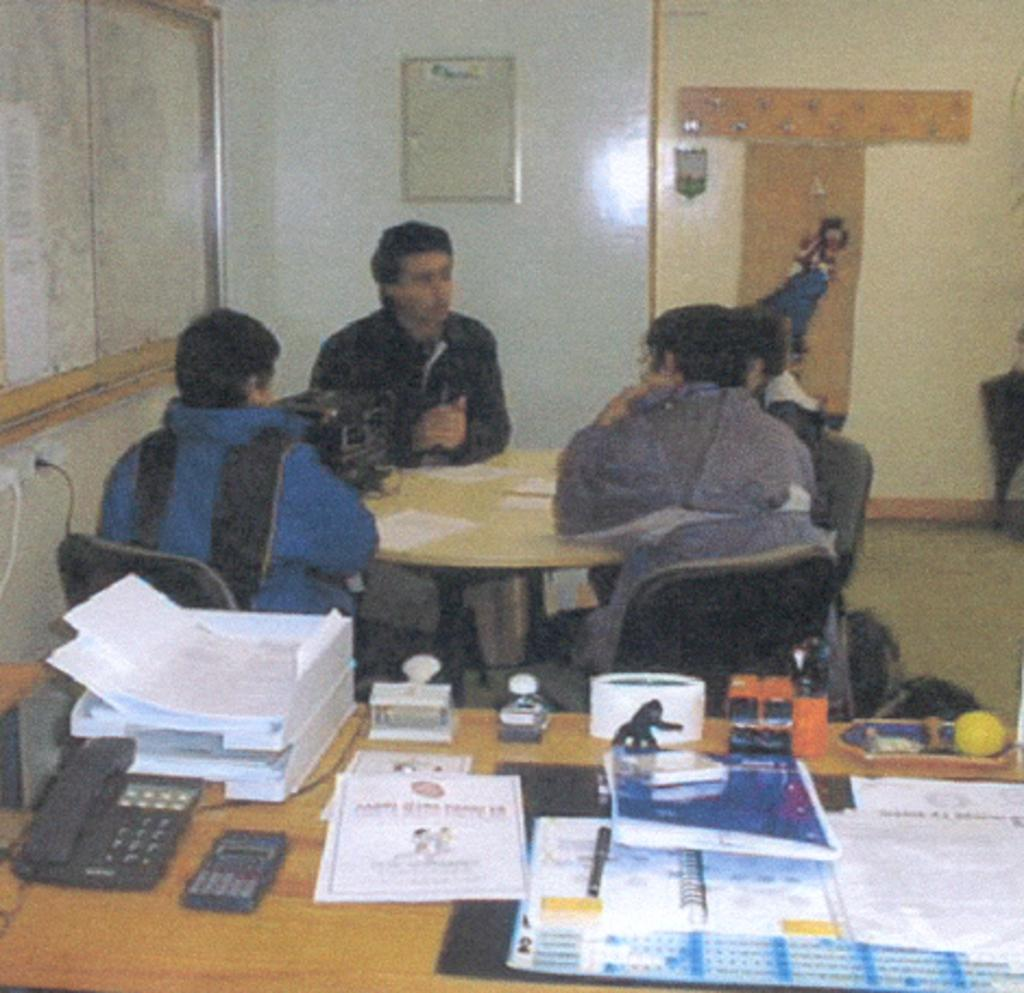What are the people in the image doing? The people in the image are sitting on chairs. What objects can be seen on the tables in the image? Papers, a telephone, and a calculator are visible on the tables. What else is present on the tables, besides the mentioned items? There are other unspecified things on the tables. What can be seen on the wall in the image? Boards are on the wall. What color is the ink on the lips of the person sitting on the chair? There is no mention of ink or lips in the image, so this detail cannot be determined. 